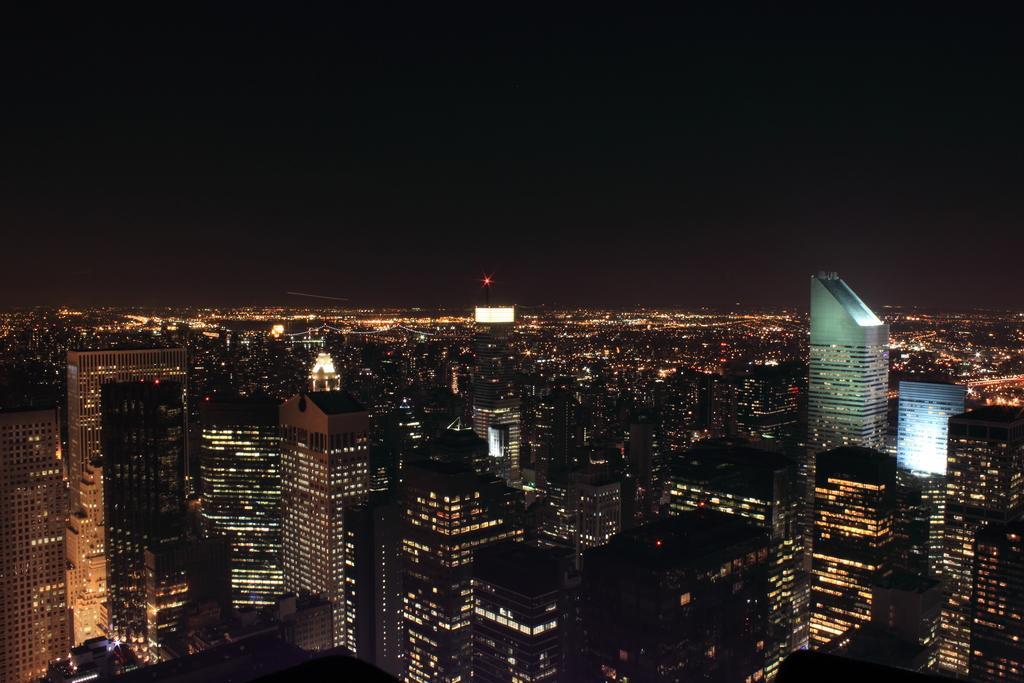Describe this image in one or two sentences. As we can see in the image there are buildings, lights and sky. 